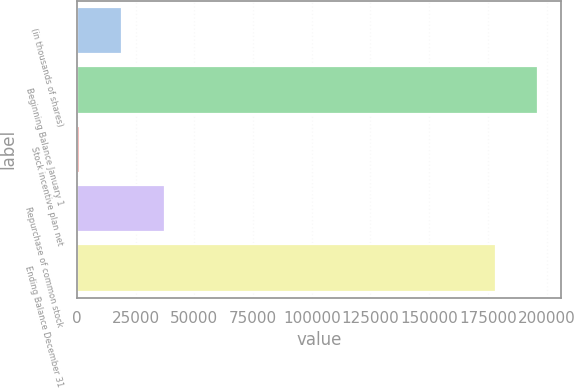<chart> <loc_0><loc_0><loc_500><loc_500><bar_chart><fcel>(in thousands of shares)<fcel>Beginning Balance January 1<fcel>Stock incentive plan net<fcel>Repurchase of common stock<fcel>Ending Balance December 31<nl><fcel>19382<fcel>196479<fcel>1280<fcel>37484<fcel>178377<nl></chart> 